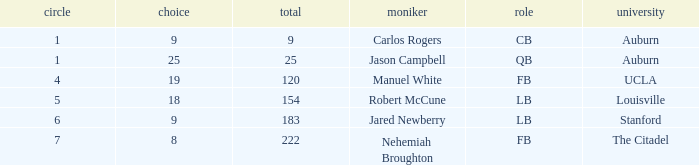Which college had an overall pick of 9? Auburn. 